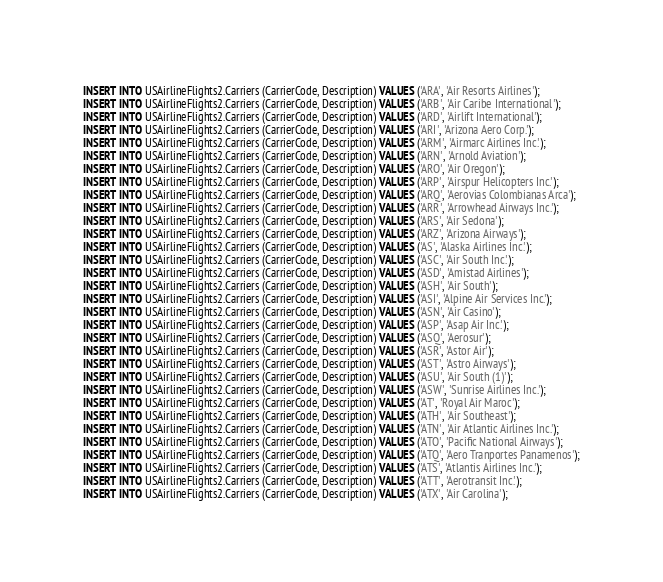<code> <loc_0><loc_0><loc_500><loc_500><_SQL_>INSERT INTO USAirlineFlights2.Carriers (CarrierCode, Description) VALUES ('ARA', 'Air Resorts Airlines');
INSERT INTO USAirlineFlights2.Carriers (CarrierCode, Description) VALUES ('ARB', 'Air Caribe International');
INSERT INTO USAirlineFlights2.Carriers (CarrierCode, Description) VALUES ('ARD', 'Airlift International');
INSERT INTO USAirlineFlights2.Carriers (CarrierCode, Description) VALUES ('ARI', 'Arizona Aero Corp.');
INSERT INTO USAirlineFlights2.Carriers (CarrierCode, Description) VALUES ('ARM', 'Airmarc Airlines Inc.');
INSERT INTO USAirlineFlights2.Carriers (CarrierCode, Description) VALUES ('ARN', 'Arnold Aviation');
INSERT INTO USAirlineFlights2.Carriers (CarrierCode, Description) VALUES ('ARO', 'Air Oregon');
INSERT INTO USAirlineFlights2.Carriers (CarrierCode, Description) VALUES ('ARP', 'Airspur Helicopters Inc.');
INSERT INTO USAirlineFlights2.Carriers (CarrierCode, Description) VALUES ('ARQ', 'Aerovias Colombianas Arca');
INSERT INTO USAirlineFlights2.Carriers (CarrierCode, Description) VALUES ('ARR', 'Arrowhead Airways Inc.');
INSERT INTO USAirlineFlights2.Carriers (CarrierCode, Description) VALUES ('ARS', 'Air Sedona');
INSERT INTO USAirlineFlights2.Carriers (CarrierCode, Description) VALUES ('ARZ', 'Arizona Airways');
INSERT INTO USAirlineFlights2.Carriers (CarrierCode, Description) VALUES ('AS', 'Alaska Airlines Inc.');
INSERT INTO USAirlineFlights2.Carriers (CarrierCode, Description) VALUES ('ASC', 'Air South Inc.');
INSERT INTO USAirlineFlights2.Carriers (CarrierCode, Description) VALUES ('ASD', 'Amistad Airlines');
INSERT INTO USAirlineFlights2.Carriers (CarrierCode, Description) VALUES ('ASH', 'Air South');
INSERT INTO USAirlineFlights2.Carriers (CarrierCode, Description) VALUES ('ASI', 'Alpine Air Services Inc.');
INSERT INTO USAirlineFlights2.Carriers (CarrierCode, Description) VALUES ('ASN', 'Air Casino');
INSERT INTO USAirlineFlights2.Carriers (CarrierCode, Description) VALUES ('ASP', 'Asap Air Inc.');
INSERT INTO USAirlineFlights2.Carriers (CarrierCode, Description) VALUES ('ASQ', 'Aerosur');
INSERT INTO USAirlineFlights2.Carriers (CarrierCode, Description) VALUES ('ASR', 'Astor Air');
INSERT INTO USAirlineFlights2.Carriers (CarrierCode, Description) VALUES ('AST', 'Astro Airways');
INSERT INTO USAirlineFlights2.Carriers (CarrierCode, Description) VALUES ('ASU', 'Air South (1)');
INSERT INTO USAirlineFlights2.Carriers (CarrierCode, Description) VALUES ('ASW', 'Sunrise Airlines Inc.');
INSERT INTO USAirlineFlights2.Carriers (CarrierCode, Description) VALUES ('AT', 'Royal Air Maroc');
INSERT INTO USAirlineFlights2.Carriers (CarrierCode, Description) VALUES ('ATH', 'Air Southeast');
INSERT INTO USAirlineFlights2.Carriers (CarrierCode, Description) VALUES ('ATN', 'Air Atlantic Airlines Inc.');
INSERT INTO USAirlineFlights2.Carriers (CarrierCode, Description) VALUES ('ATO', 'Pacific National Airways');
INSERT INTO USAirlineFlights2.Carriers (CarrierCode, Description) VALUES ('ATQ', 'Aero Tranportes Panamenos');
INSERT INTO USAirlineFlights2.Carriers (CarrierCode, Description) VALUES ('ATS', 'Atlantis Airlines Inc.');
INSERT INTO USAirlineFlights2.Carriers (CarrierCode, Description) VALUES ('ATT', 'Aerotransit Inc.');
INSERT INTO USAirlineFlights2.Carriers (CarrierCode, Description) VALUES ('ATX', 'Air Carolina');</code> 